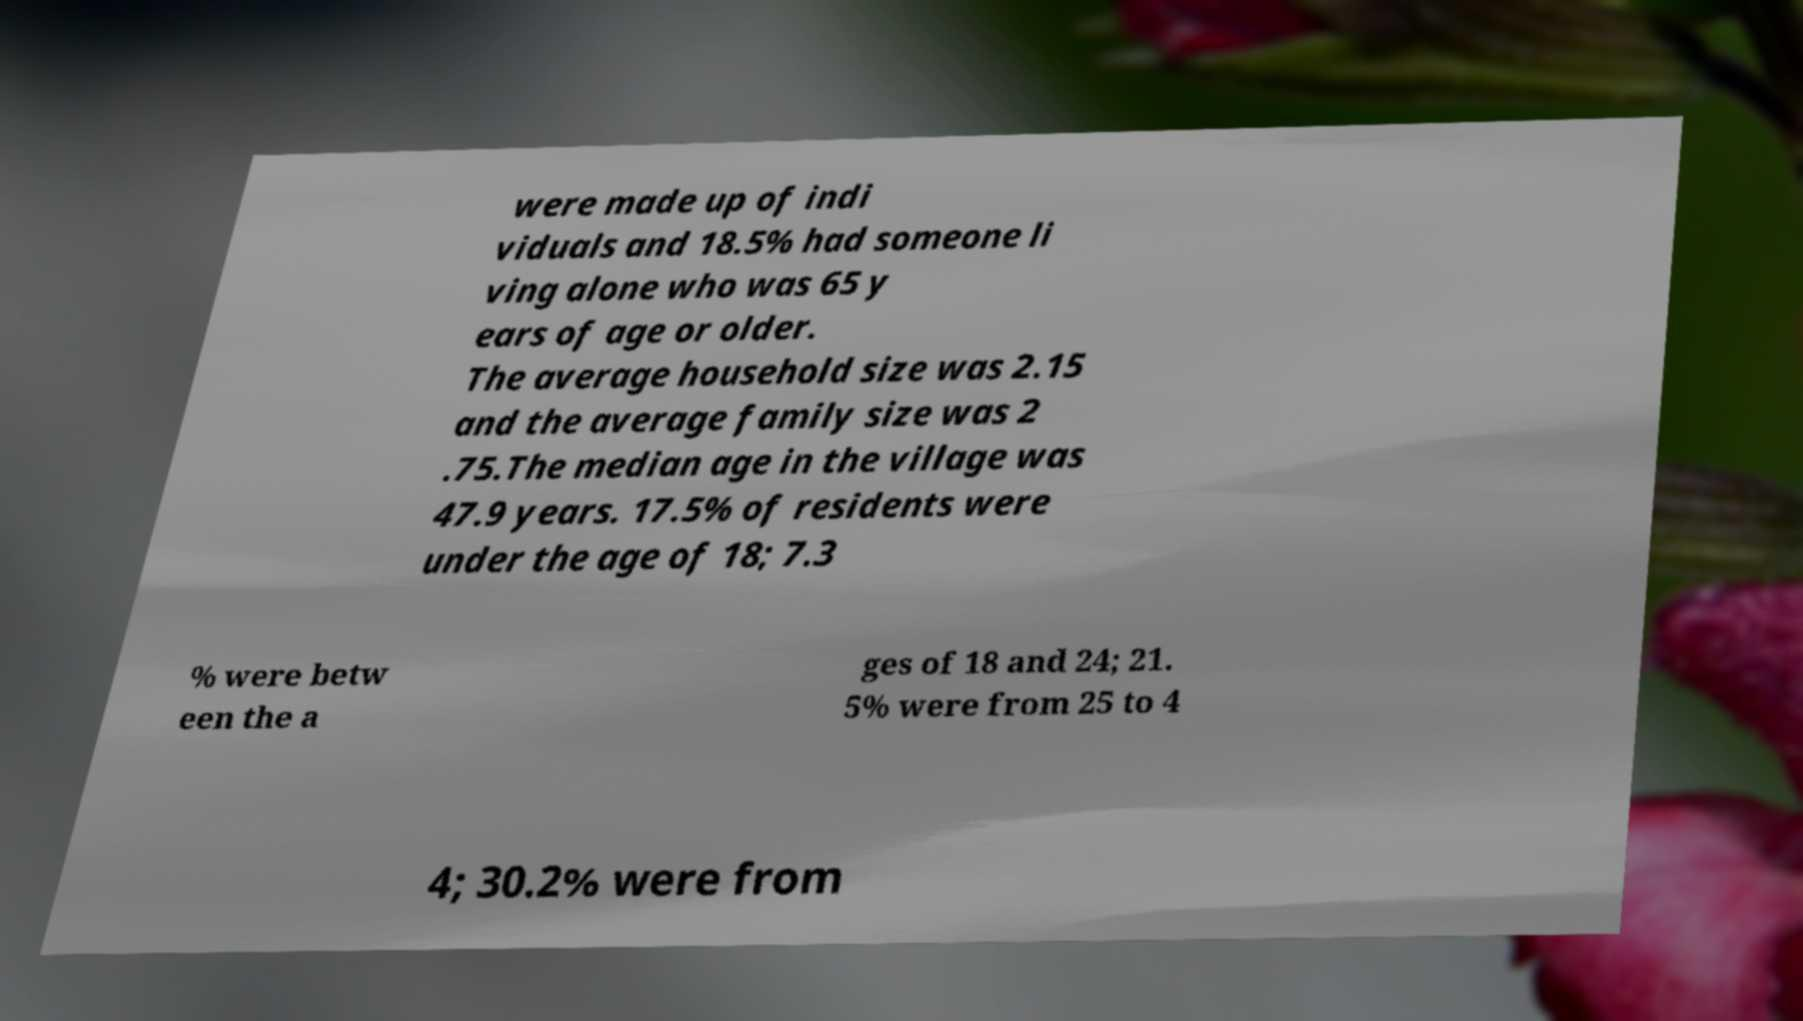There's text embedded in this image that I need extracted. Can you transcribe it verbatim? were made up of indi viduals and 18.5% had someone li ving alone who was 65 y ears of age or older. The average household size was 2.15 and the average family size was 2 .75.The median age in the village was 47.9 years. 17.5% of residents were under the age of 18; 7.3 % were betw een the a ges of 18 and 24; 21. 5% were from 25 to 4 4; 30.2% were from 